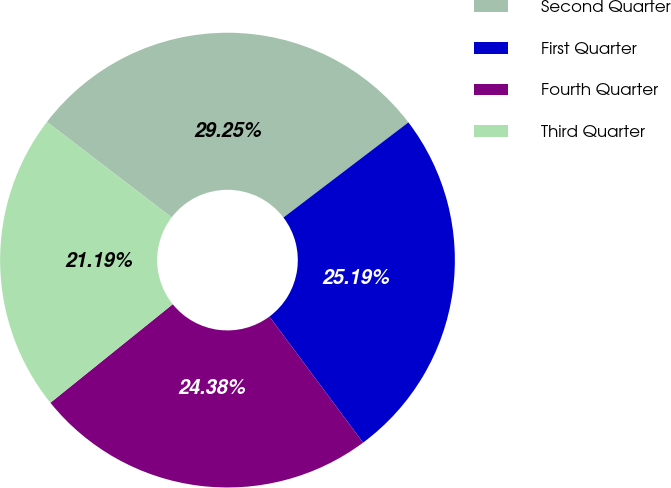Convert chart. <chart><loc_0><loc_0><loc_500><loc_500><pie_chart><fcel>Second Quarter<fcel>First Quarter<fcel>Fourth Quarter<fcel>Third Quarter<nl><fcel>29.25%<fcel>25.19%<fcel>24.38%<fcel>21.19%<nl></chart> 